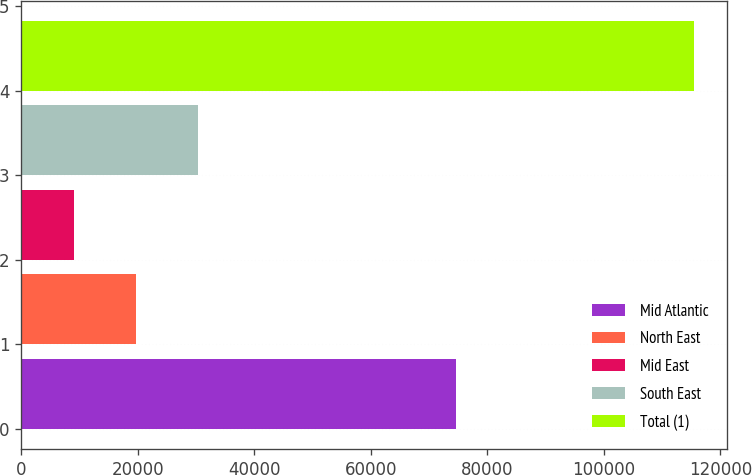Convert chart. <chart><loc_0><loc_0><loc_500><loc_500><bar_chart><fcel>Mid Atlantic<fcel>North East<fcel>Mid East<fcel>South East<fcel>Total (1)<nl><fcel>74689<fcel>19683.8<fcel>9045<fcel>30322.6<fcel>115433<nl></chart> 